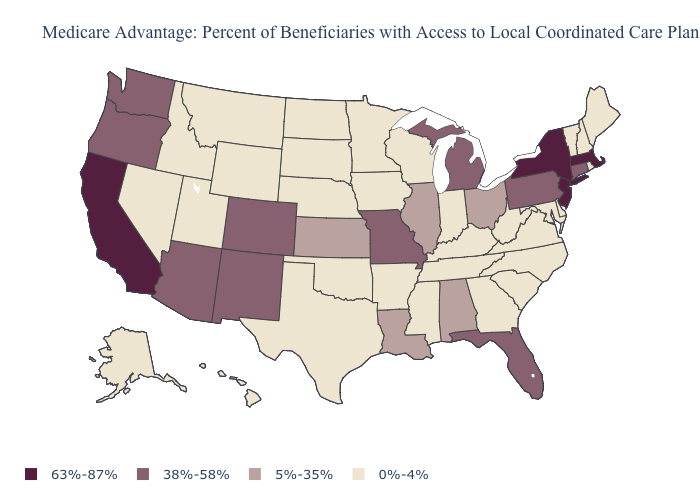Name the states that have a value in the range 63%-87%?
Give a very brief answer. California, Massachusetts, New Jersey, New York. Name the states that have a value in the range 0%-4%?
Concise answer only. Alaska, Arkansas, Delaware, Georgia, Hawaii, Iowa, Idaho, Indiana, Kentucky, Maryland, Maine, Minnesota, Mississippi, Montana, North Carolina, North Dakota, Nebraska, New Hampshire, Nevada, Oklahoma, Rhode Island, South Carolina, South Dakota, Tennessee, Texas, Utah, Virginia, Vermont, Wisconsin, West Virginia, Wyoming. What is the highest value in the West ?
Give a very brief answer. 63%-87%. What is the value of Alabama?
Be succinct. 5%-35%. Among the states that border Georgia , which have the lowest value?
Write a very short answer. North Carolina, South Carolina, Tennessee. Does the map have missing data?
Keep it brief. No. Does California have the highest value in the USA?
Be succinct. Yes. What is the lowest value in states that border Massachusetts?
Give a very brief answer. 0%-4%. Name the states that have a value in the range 63%-87%?
Quick response, please. California, Massachusetts, New Jersey, New York. What is the value of Nebraska?
Be succinct. 0%-4%. Name the states that have a value in the range 0%-4%?
Short answer required. Alaska, Arkansas, Delaware, Georgia, Hawaii, Iowa, Idaho, Indiana, Kentucky, Maryland, Maine, Minnesota, Mississippi, Montana, North Carolina, North Dakota, Nebraska, New Hampshire, Nevada, Oklahoma, Rhode Island, South Carolina, South Dakota, Tennessee, Texas, Utah, Virginia, Vermont, Wisconsin, West Virginia, Wyoming. Name the states that have a value in the range 5%-35%?
Keep it brief. Alabama, Illinois, Kansas, Louisiana, Ohio. Does California have a lower value than Rhode Island?
Concise answer only. No. Among the states that border Nevada , does Arizona have the highest value?
Answer briefly. No. What is the highest value in the MidWest ?
Answer briefly. 38%-58%. 